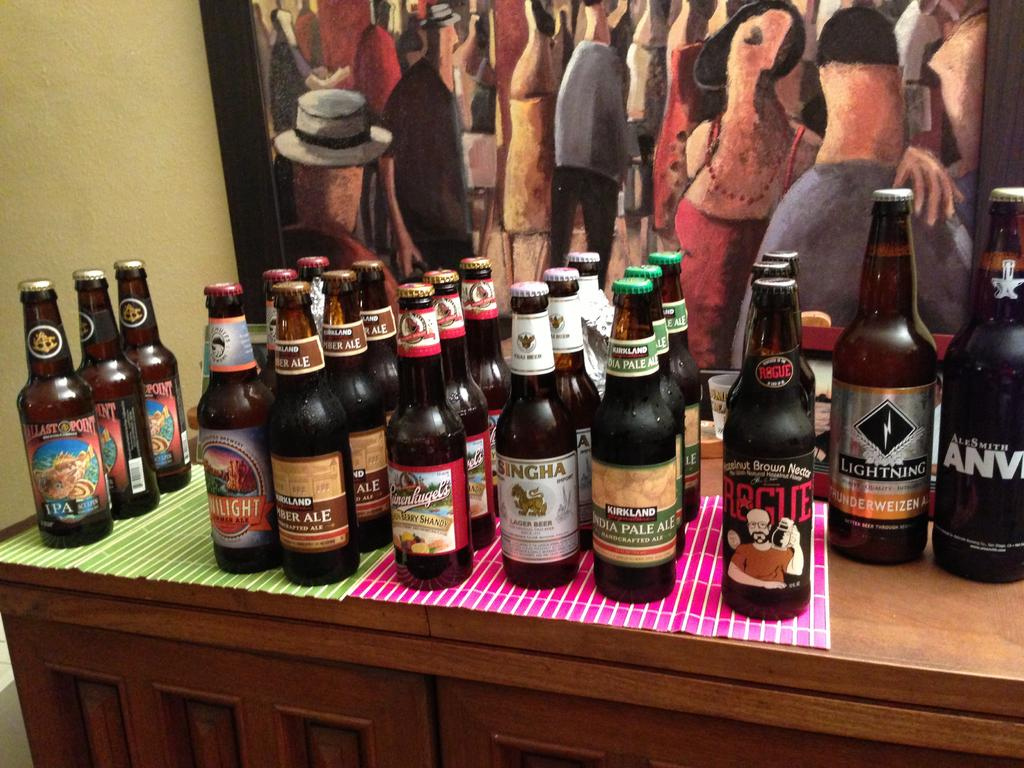<image>
Describe the image concisely. The brand of beer on the far left is Ballast Point 